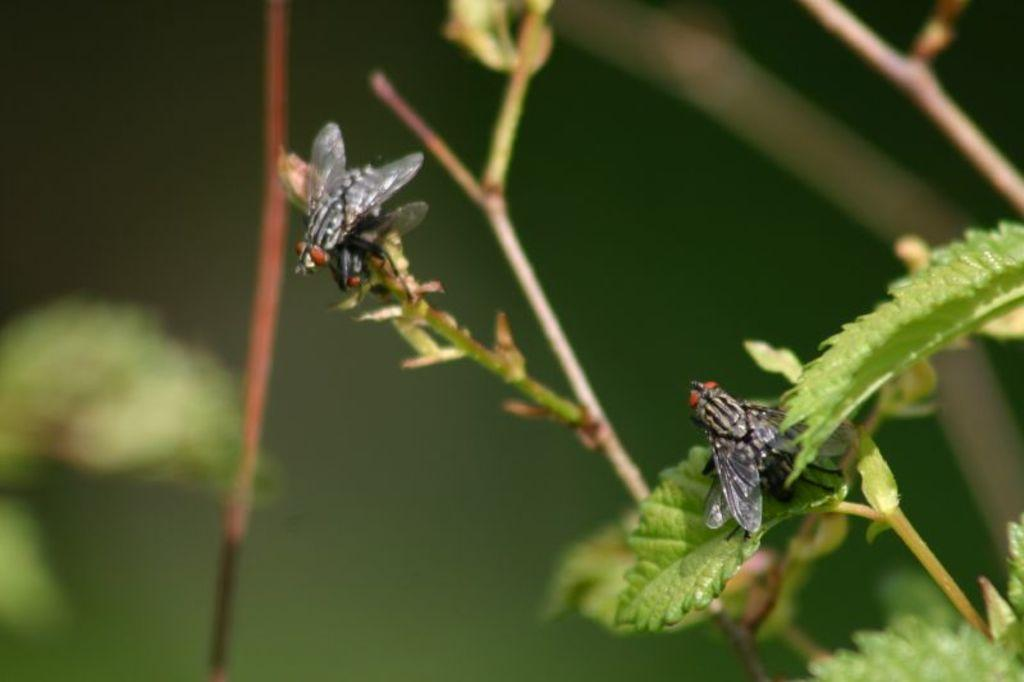What type of insects can be seen on the plant in the image? There are flies on a plant in the image. Can you describe the plant that the flies are on? Unfortunately, the facts provided do not give any details about the plant. Are there any other living organisms visible in the image besides the flies? The facts provided do not mention any other living organisms. What type of pets are visible in the image? There are no pets visible in the image; it only features flies on a plant. How many members are in the group of people in the image? There is no group of people present in the image; it only features flies on a plant. 